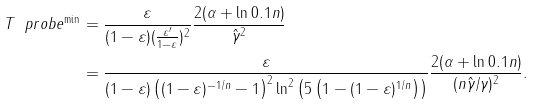<formula> <loc_0><loc_0><loc_500><loc_500>T \ p r o b e ^ { \min } & = \frac { \varepsilon } { ( 1 - \varepsilon ) ( \frac { \varepsilon ^ { \prime } } { 1 - \varepsilon } ) ^ { 2 } } \frac { 2 ( \alpha + \ln 0 . 1 n ) } { \hat { \gamma } ^ { 2 } } \\ & = \frac { \varepsilon } { ( 1 - \varepsilon ) \left ( ( 1 - \varepsilon ) ^ { - 1 / n } - 1 \right ) ^ { 2 } \ln ^ { 2 } \left ( 5 \left ( 1 - ( 1 - \varepsilon ) ^ { 1 / n } \right ) \right ) } \frac { 2 ( \alpha + \ln 0 . 1 n ) } { ( n \hat { \gamma } / \gamma ) ^ { 2 } } .</formula> 